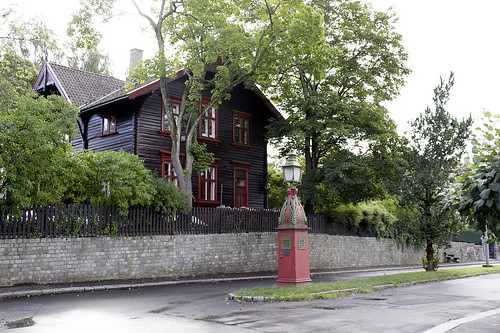<image>
Is there a tree behind the house? No. The tree is not behind the house. From this viewpoint, the tree appears to be positioned elsewhere in the scene. 